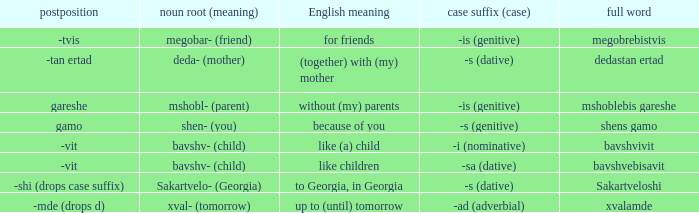What is Postposition, when Noun Root (Meaning) is "mshobl- (parent)"? Gareshe. 